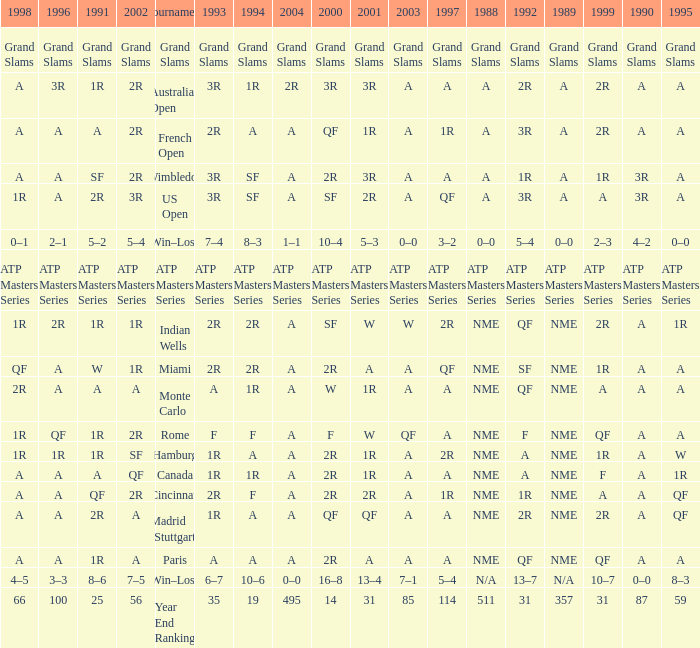What shows for 1988 when 1994 shows 10–6? N/A. 